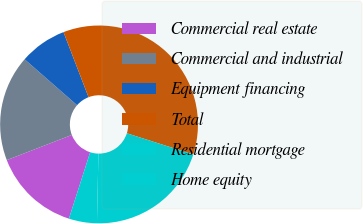Convert chart to OTSL. <chart><loc_0><loc_0><loc_500><loc_500><pie_chart><fcel>Commercial real estate<fcel>Commercial and industrial<fcel>Equipment financing<fcel>Total<fcel>Residential mortgage<fcel>Home equity<nl><fcel>14.2%<fcel>17.32%<fcel>7.71%<fcel>35.76%<fcel>20.43%<fcel>4.59%<nl></chart> 